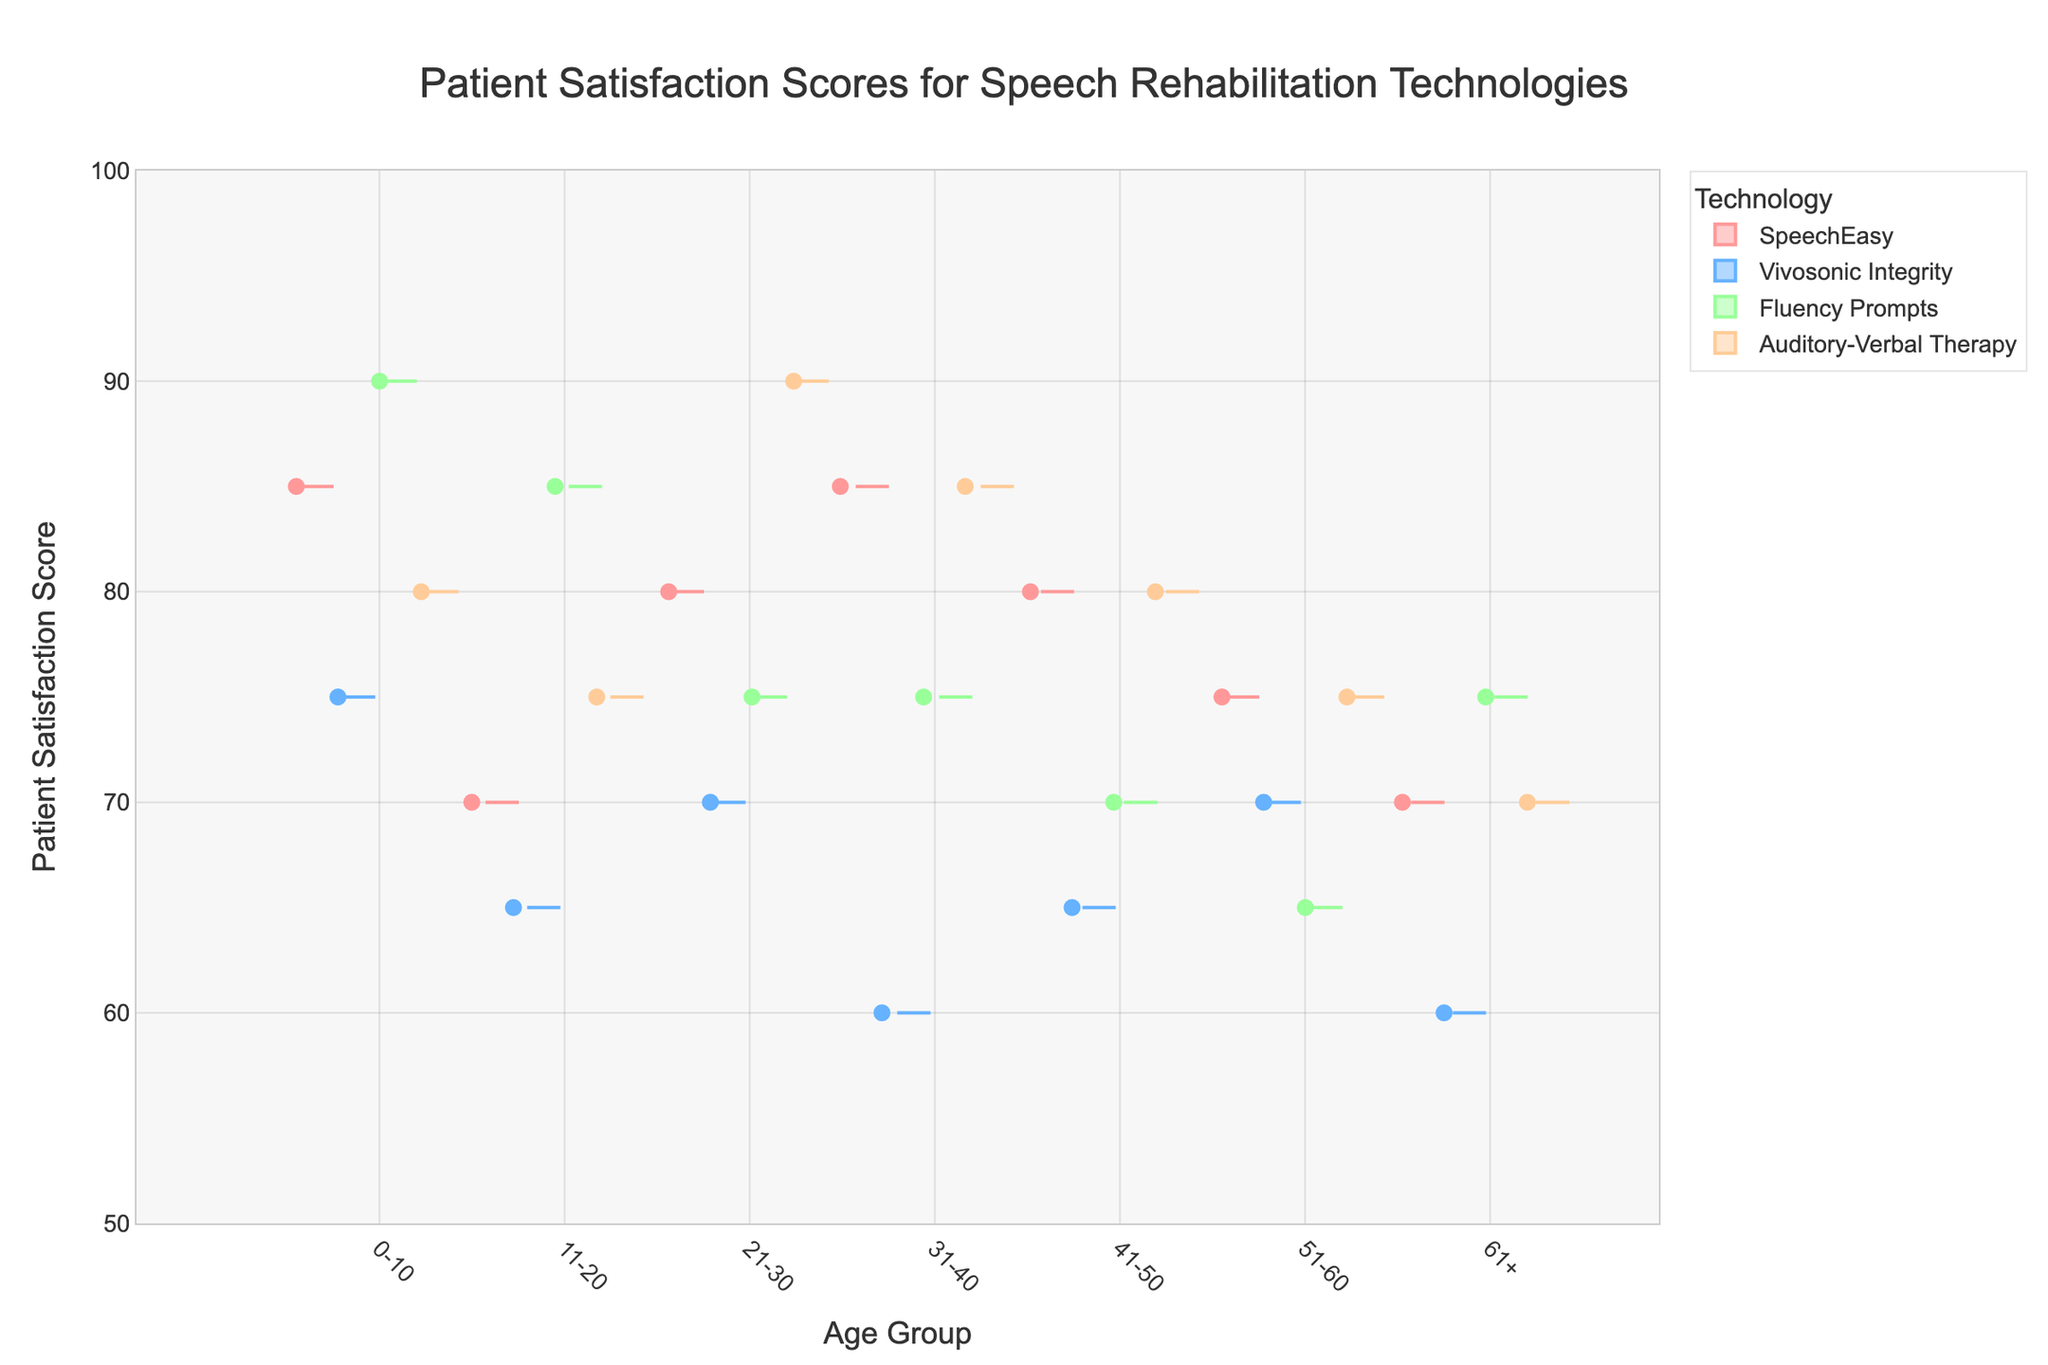What is the title of the figure? The title of the figure is located at the top and is typically a short description summarizing the content of the plot.
Answer: Patient Satisfaction Scores for Speech Rehabilitation Technologies How many age groups are represented in the figure? Look at the x-axis, which displays the different age groups in this Variable Width Box Plot. Count the distinct labels along the x-axis.
Answer: 7 Which technology has the highest median patient satisfaction score in the 0-10 age group? Locate the 0-10 age group on the x-axis, then identify the box from each technology. The median is generally marked by a line inside the box.
Answer: Fluency Prompts Which technology shows the lowest patient satisfaction score in the 31-40 age group? Find the 31-40 age group on the x-axis, and look for the lowest point of all the boxes corresponding to this age group.
Answer: Vivosonic Integrity What is the range of patient satisfaction scores for Auditory-Verbal Therapy in the 21-30 age group? Locate the box for Auditory-Verbal Therapy in the 21-30 age group. The range is from the minimum to maximum points (whiskers) of this box.
Answer: 75 to 90 Which age group has the largest variation in patient satisfaction scores for Fluency Prompts? For each age group, find the Fluency Prompts box and measure the distance from the minimum to maximum points (whiskers), representing the range. The largest range indicates the largest variation.
Answer: 0-10 How do the median satisfaction scores for SpeechEasy and Vivosonic Integrity compare across all age groups? For each age group, identify the median satisfaction score for both SpeechEasy and Vivosonic Integrity by looking for the line within each box. Compare these medians for all age groups.
Answer: SpeechEasy generally has higher medians What is the most frequent color used in the plot? Identify the colors used for each technology's boxes and count their occurrences. The color with the highest count is the most frequent.
Answer: Red (SpeechEasy) Which technology has the most consistent patient satisfaction scores across all age groups? Consistency can be inferred by looking at the variability (range and spread) of each technology's boxes across all age groups. The technology with the smallest widths and ranges is the most consistent.
Answer: Auditory-Verbal Therapy 